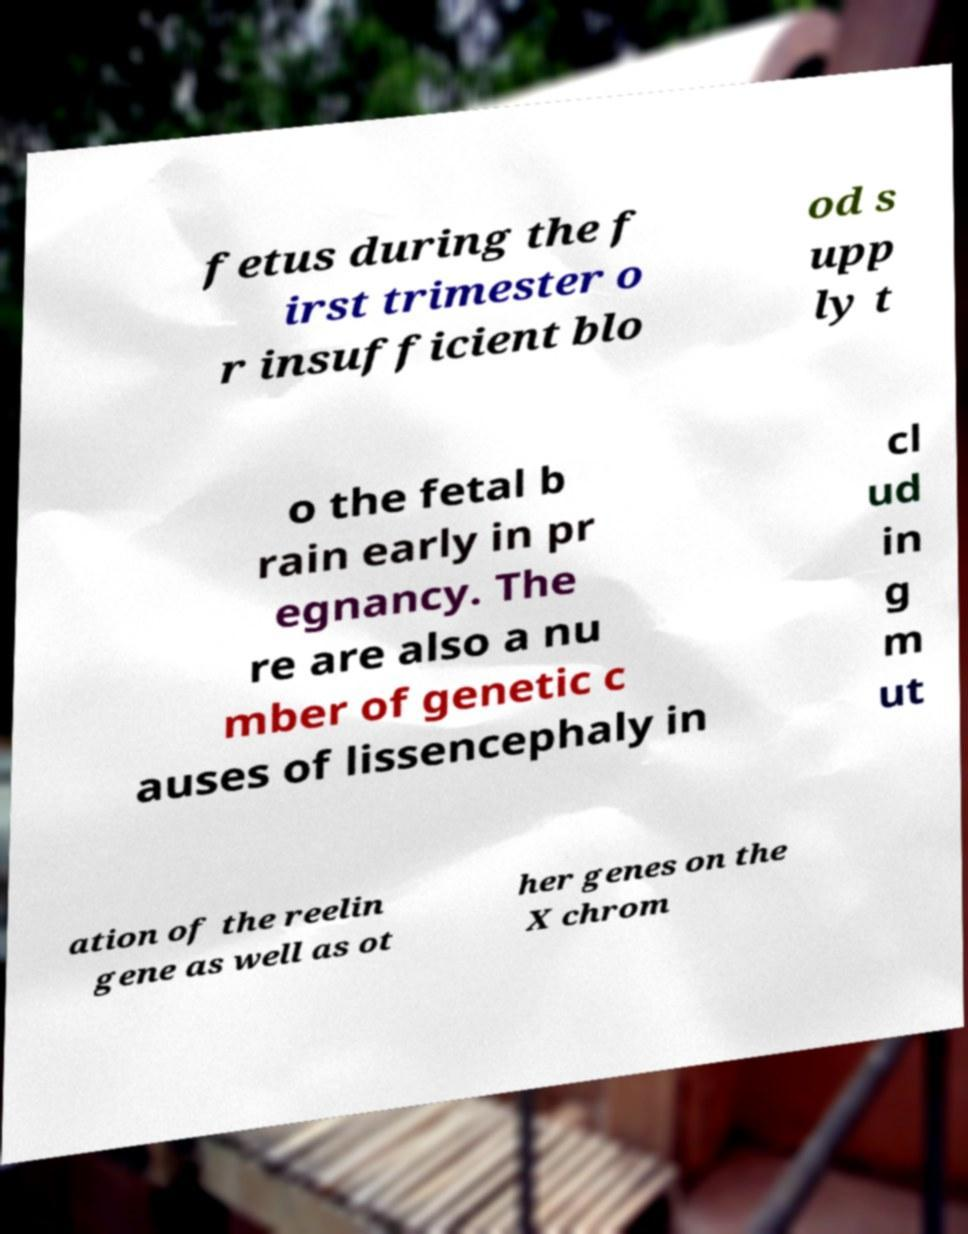There's text embedded in this image that I need extracted. Can you transcribe it verbatim? fetus during the f irst trimester o r insufficient blo od s upp ly t o the fetal b rain early in pr egnancy. The re are also a nu mber of genetic c auses of lissencephaly in cl ud in g m ut ation of the reelin gene as well as ot her genes on the X chrom 